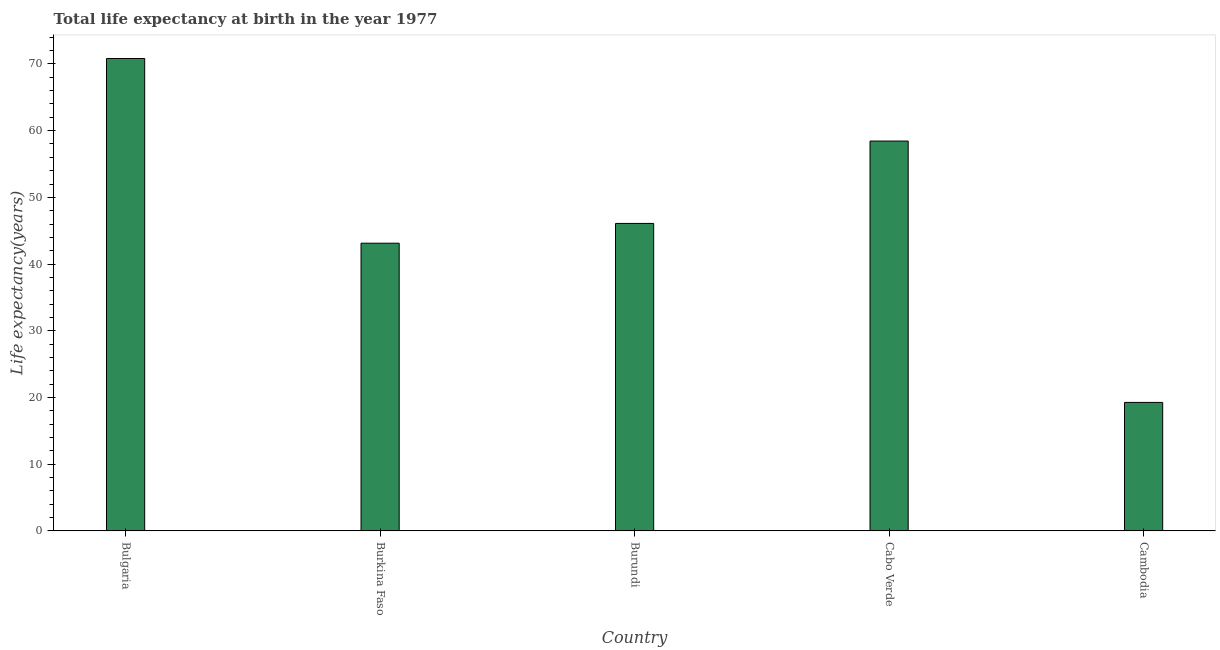Does the graph contain grids?
Your response must be concise. No. What is the title of the graph?
Provide a succinct answer. Total life expectancy at birth in the year 1977. What is the label or title of the X-axis?
Give a very brief answer. Country. What is the label or title of the Y-axis?
Provide a succinct answer. Life expectancy(years). What is the life expectancy at birth in Cabo Verde?
Offer a very short reply. 58.44. Across all countries, what is the maximum life expectancy at birth?
Provide a succinct answer. 70.82. Across all countries, what is the minimum life expectancy at birth?
Offer a terse response. 19.27. In which country was the life expectancy at birth maximum?
Provide a short and direct response. Bulgaria. In which country was the life expectancy at birth minimum?
Your answer should be very brief. Cambodia. What is the sum of the life expectancy at birth?
Give a very brief answer. 237.75. What is the difference between the life expectancy at birth in Burundi and Cambodia?
Your answer should be compact. 26.83. What is the average life expectancy at birth per country?
Keep it short and to the point. 47.55. What is the median life expectancy at birth?
Offer a terse response. 46.09. In how many countries, is the life expectancy at birth greater than 70 years?
Make the answer very short. 1. What is the ratio of the life expectancy at birth in Burkina Faso to that in Cambodia?
Your response must be concise. 2.24. Is the life expectancy at birth in Bulgaria less than that in Cambodia?
Your answer should be very brief. No. What is the difference between the highest and the second highest life expectancy at birth?
Provide a short and direct response. 12.37. Is the sum of the life expectancy at birth in Burundi and Cabo Verde greater than the maximum life expectancy at birth across all countries?
Make the answer very short. Yes. What is the difference between the highest and the lowest life expectancy at birth?
Make the answer very short. 51.55. How many bars are there?
Make the answer very short. 5. Are all the bars in the graph horizontal?
Make the answer very short. No. What is the difference between two consecutive major ticks on the Y-axis?
Keep it short and to the point. 10. What is the Life expectancy(years) of Bulgaria?
Your answer should be very brief. 70.82. What is the Life expectancy(years) in Burkina Faso?
Offer a very short reply. 43.13. What is the Life expectancy(years) of Burundi?
Your response must be concise. 46.09. What is the Life expectancy(years) in Cabo Verde?
Make the answer very short. 58.44. What is the Life expectancy(years) of Cambodia?
Offer a very short reply. 19.27. What is the difference between the Life expectancy(years) in Bulgaria and Burkina Faso?
Offer a terse response. 27.69. What is the difference between the Life expectancy(years) in Bulgaria and Burundi?
Give a very brief answer. 24.72. What is the difference between the Life expectancy(years) in Bulgaria and Cabo Verde?
Offer a very short reply. 12.37. What is the difference between the Life expectancy(years) in Bulgaria and Cambodia?
Your answer should be very brief. 51.55. What is the difference between the Life expectancy(years) in Burkina Faso and Burundi?
Your answer should be compact. -2.96. What is the difference between the Life expectancy(years) in Burkina Faso and Cabo Verde?
Offer a very short reply. -15.31. What is the difference between the Life expectancy(years) in Burkina Faso and Cambodia?
Ensure brevity in your answer.  23.86. What is the difference between the Life expectancy(years) in Burundi and Cabo Verde?
Provide a short and direct response. -12.35. What is the difference between the Life expectancy(years) in Burundi and Cambodia?
Your answer should be very brief. 26.83. What is the difference between the Life expectancy(years) in Cabo Verde and Cambodia?
Offer a very short reply. 39.18. What is the ratio of the Life expectancy(years) in Bulgaria to that in Burkina Faso?
Keep it short and to the point. 1.64. What is the ratio of the Life expectancy(years) in Bulgaria to that in Burundi?
Provide a short and direct response. 1.54. What is the ratio of the Life expectancy(years) in Bulgaria to that in Cabo Verde?
Make the answer very short. 1.21. What is the ratio of the Life expectancy(years) in Bulgaria to that in Cambodia?
Your answer should be compact. 3.68. What is the ratio of the Life expectancy(years) in Burkina Faso to that in Burundi?
Your answer should be compact. 0.94. What is the ratio of the Life expectancy(years) in Burkina Faso to that in Cabo Verde?
Provide a succinct answer. 0.74. What is the ratio of the Life expectancy(years) in Burkina Faso to that in Cambodia?
Keep it short and to the point. 2.24. What is the ratio of the Life expectancy(years) in Burundi to that in Cabo Verde?
Your answer should be compact. 0.79. What is the ratio of the Life expectancy(years) in Burundi to that in Cambodia?
Keep it short and to the point. 2.39. What is the ratio of the Life expectancy(years) in Cabo Verde to that in Cambodia?
Give a very brief answer. 3.03. 